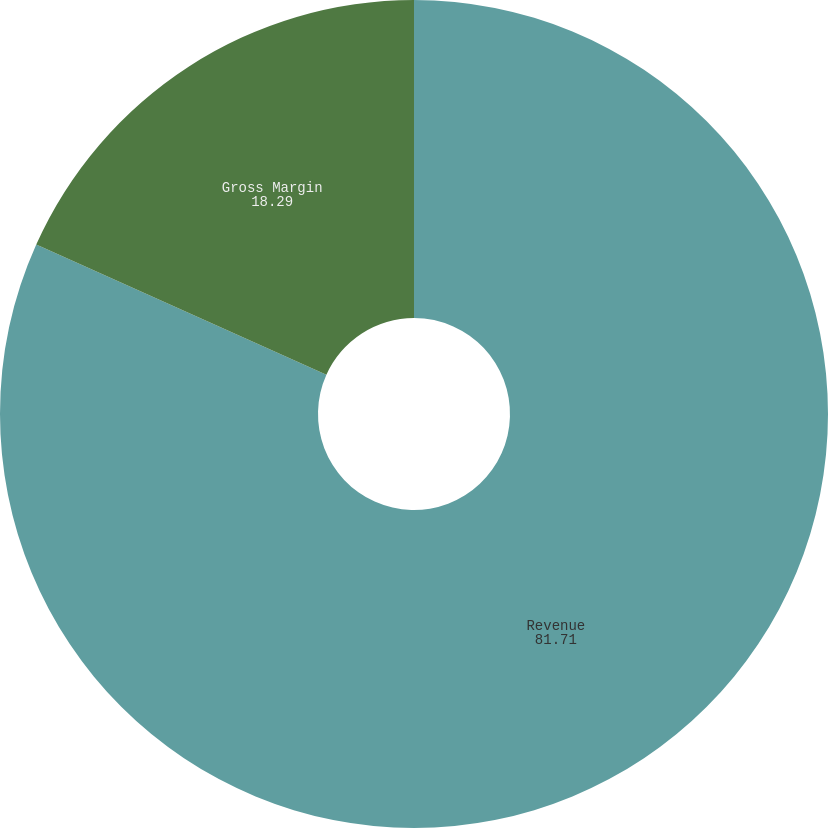<chart> <loc_0><loc_0><loc_500><loc_500><pie_chart><fcel>Revenue<fcel>Gross Margin<nl><fcel>81.71%<fcel>18.29%<nl></chart> 